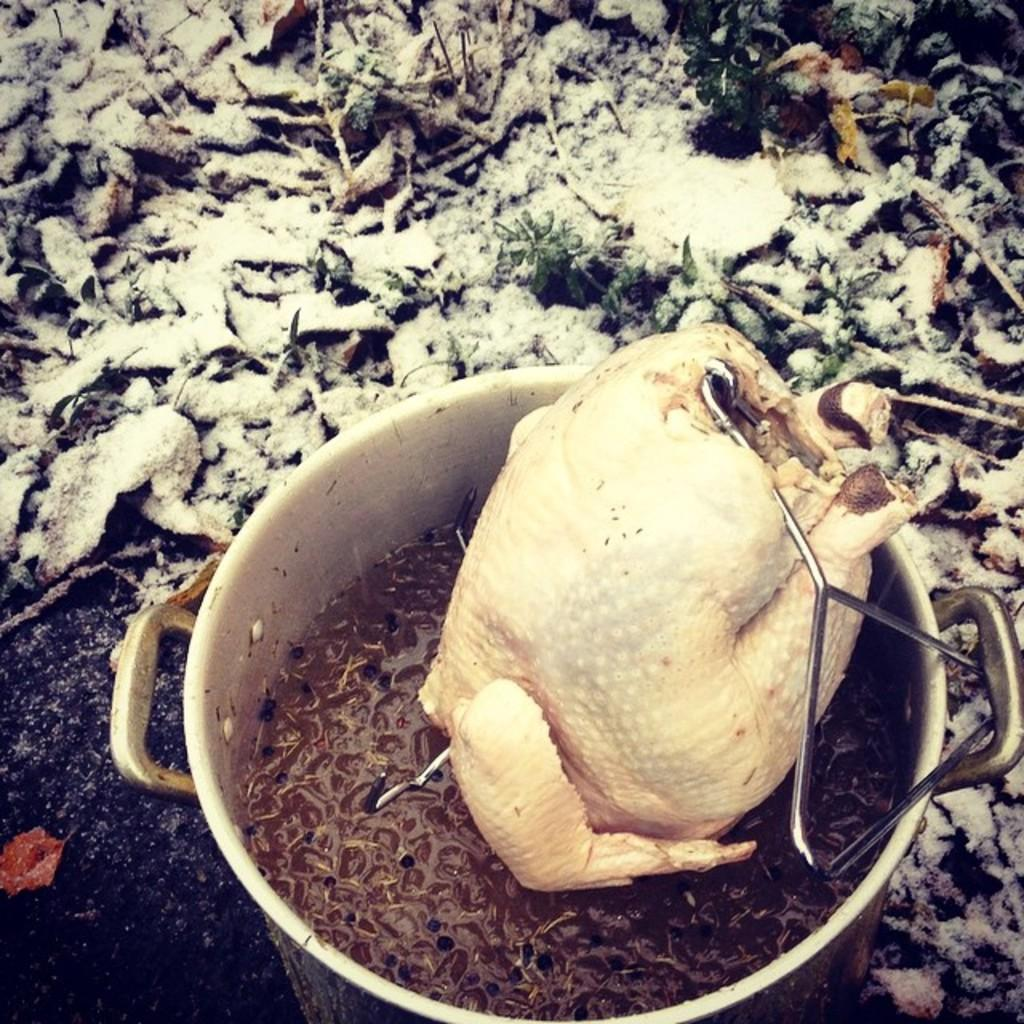What is the main object in the image? There is a container in the image. What is inside the container? The container holds a brown-colored thing. What animal is present in the image? There is a chicken in the image. How is the chicken positioned or modified? The chicken has metal rods inserted. What else can be seen on the ground in the image? There are other objects on the ground in the image. Where is the bed located in the image? There is no bed present in the image. What type of chain can be seen connecting the mailbox to the ground? There is no mailbox or chain present in the image. 